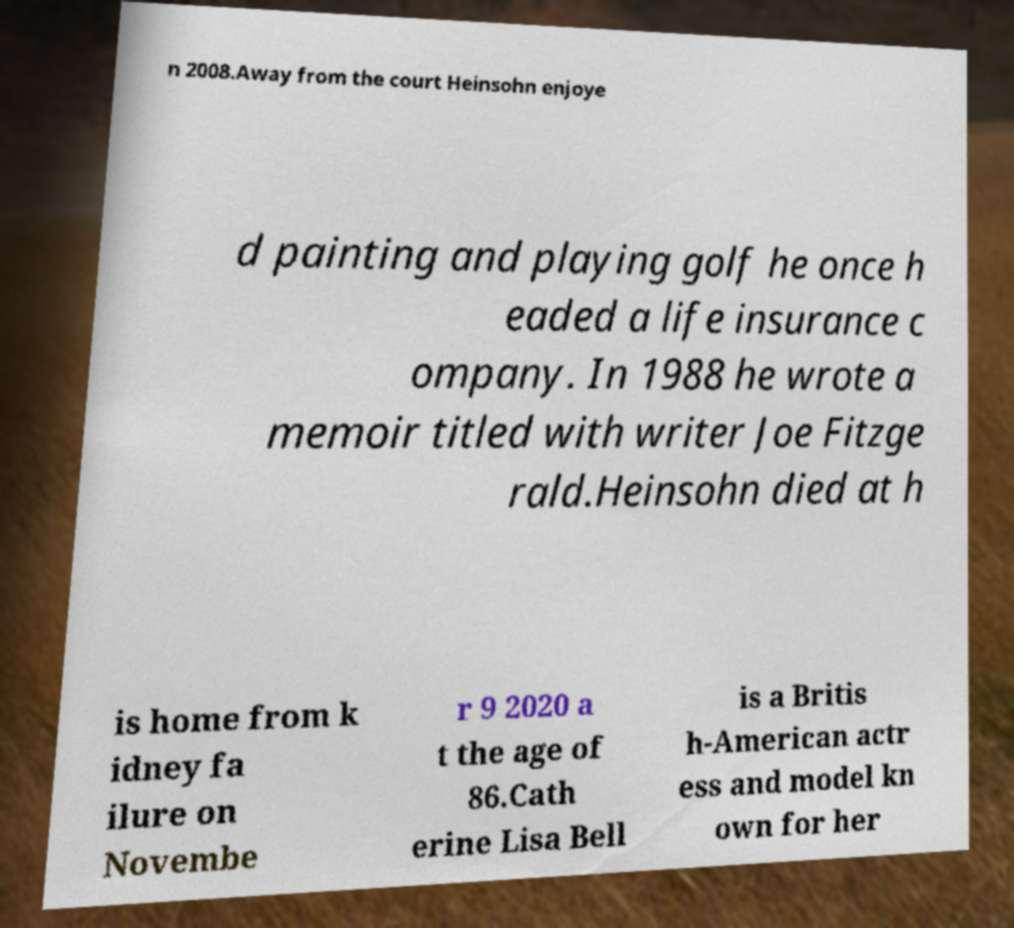For documentation purposes, I need the text within this image transcribed. Could you provide that? n 2008.Away from the court Heinsohn enjoye d painting and playing golf he once h eaded a life insurance c ompany. In 1988 he wrote a memoir titled with writer Joe Fitzge rald.Heinsohn died at h is home from k idney fa ilure on Novembe r 9 2020 a t the age of 86.Cath erine Lisa Bell is a Britis h-American actr ess and model kn own for her 